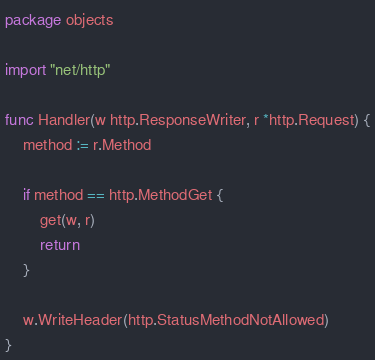Convert code to text. <code><loc_0><loc_0><loc_500><loc_500><_Go_>package objects

import "net/http"

func Handler(w http.ResponseWriter, r *http.Request) {
    method := r.Method

    if method == http.MethodGet {
        get(w, r)
        return
    }

    w.WriteHeader(http.StatusMethodNotAllowed)
}
</code> 